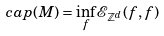<formula> <loc_0><loc_0><loc_500><loc_500>c a p ( M ) = \inf _ { f } \mathcal { E } _ { \mathbb { Z } ^ { d } } ( f , f )</formula> 